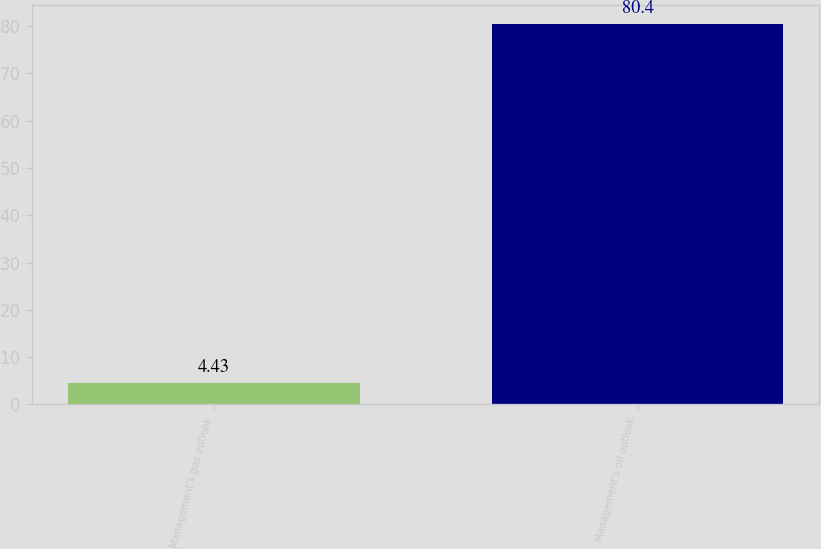Convert chart to OTSL. <chart><loc_0><loc_0><loc_500><loc_500><bar_chart><fcel>Management's gas outlook<fcel>Management's oil outlook<nl><fcel>4.43<fcel>80.4<nl></chart> 